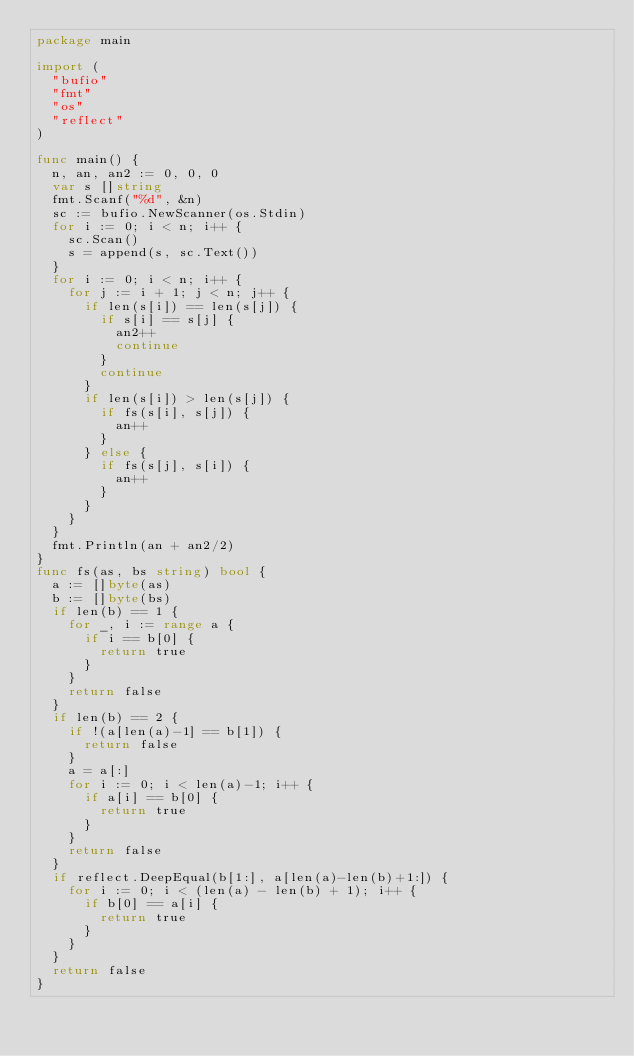<code> <loc_0><loc_0><loc_500><loc_500><_Go_>package main

import (
	"bufio"
	"fmt"
	"os"
	"reflect"
)

func main() {
	n, an, an2 := 0, 0, 0
	var s []string
	fmt.Scanf("%d", &n)
	sc := bufio.NewScanner(os.Stdin)
	for i := 0; i < n; i++ {
		sc.Scan()
		s = append(s, sc.Text())
	}
	for i := 0; i < n; i++ {
		for j := i + 1; j < n; j++ {
			if len(s[i]) == len(s[j]) {
				if s[i] == s[j] {
					an2++
					continue
				}
				continue
			}
			if len(s[i]) > len(s[j]) {
				if fs(s[i], s[j]) {
					an++
				}
			} else {
				if fs(s[j], s[i]) {
					an++
				}
			}
		}
	}
	fmt.Println(an + an2/2)
}
func fs(as, bs string) bool {
	a := []byte(as)
	b := []byte(bs)
	if len(b) == 1 {
		for _, i := range a {
			if i == b[0] {
				return true
			}
		}
		return false
	}
	if len(b) == 2 {
		if !(a[len(a)-1] == b[1]) {
			return false
		}
		a = a[:]
		for i := 0; i < len(a)-1; i++ {
			if a[i] == b[0] {
				return true
			}
		}
		return false
	}
	if reflect.DeepEqual(b[1:], a[len(a)-len(b)+1:]) {
		for i := 0; i < (len(a) - len(b) + 1); i++ {
			if b[0] == a[i] {
				return true
			}
		}
	}
	return false
}
</code> 